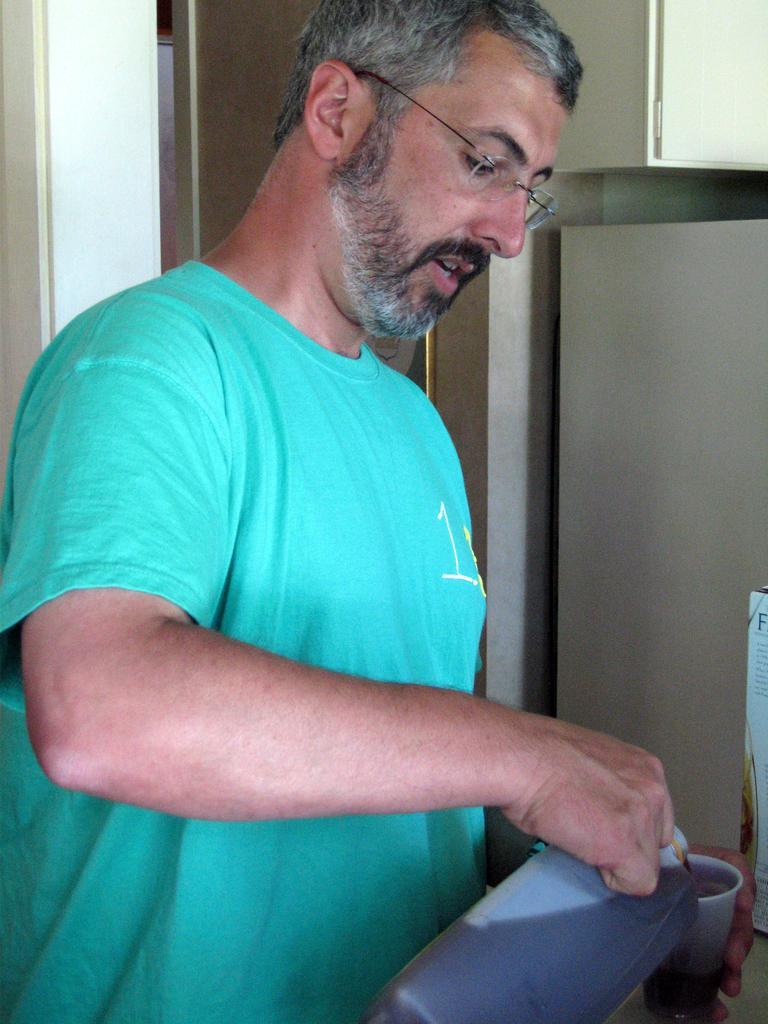In one or two sentences, can you explain what this image depicts? In this image there is a man he is wearing a T-shirt holding a bottle and cup in his hand, in the background there is a wall to that wall there is a door. 